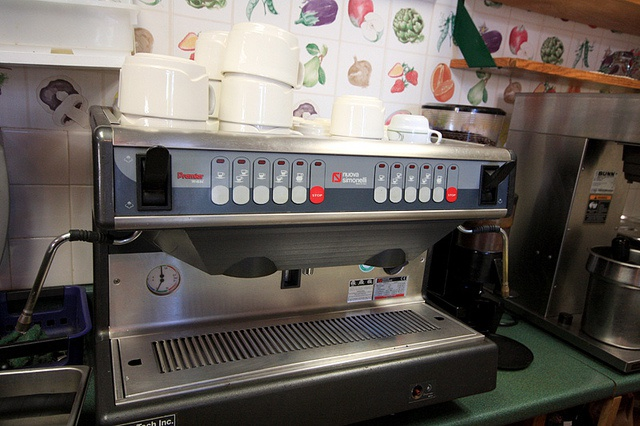Describe the objects in this image and their specific colors. I can see cup in gray, lightgray, and darkgray tones, cup in gray, ivory, lightgray, tan, and darkgray tones, cup in gray, ivory, beige, and darkgray tones, bowl in gray, black, and darkgray tones, and bowl in gray, ivory, darkgray, lightgray, and tan tones in this image. 